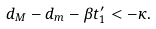<formula> <loc_0><loc_0><loc_500><loc_500>d _ { M } - d _ { m } - \beta t _ { 1 } ^ { \prime } < - \kappa .</formula> 